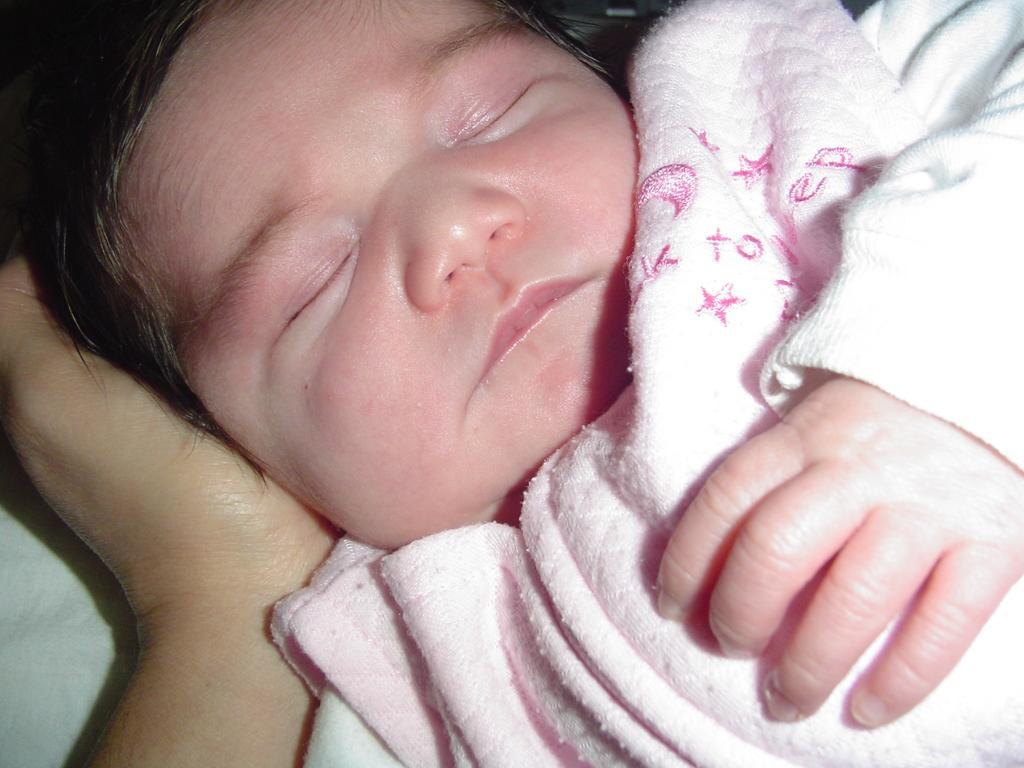Please provide a concise description of this image. In this image I can see a baby sleeping and wearing baby pink dress. I can see a person hand. 